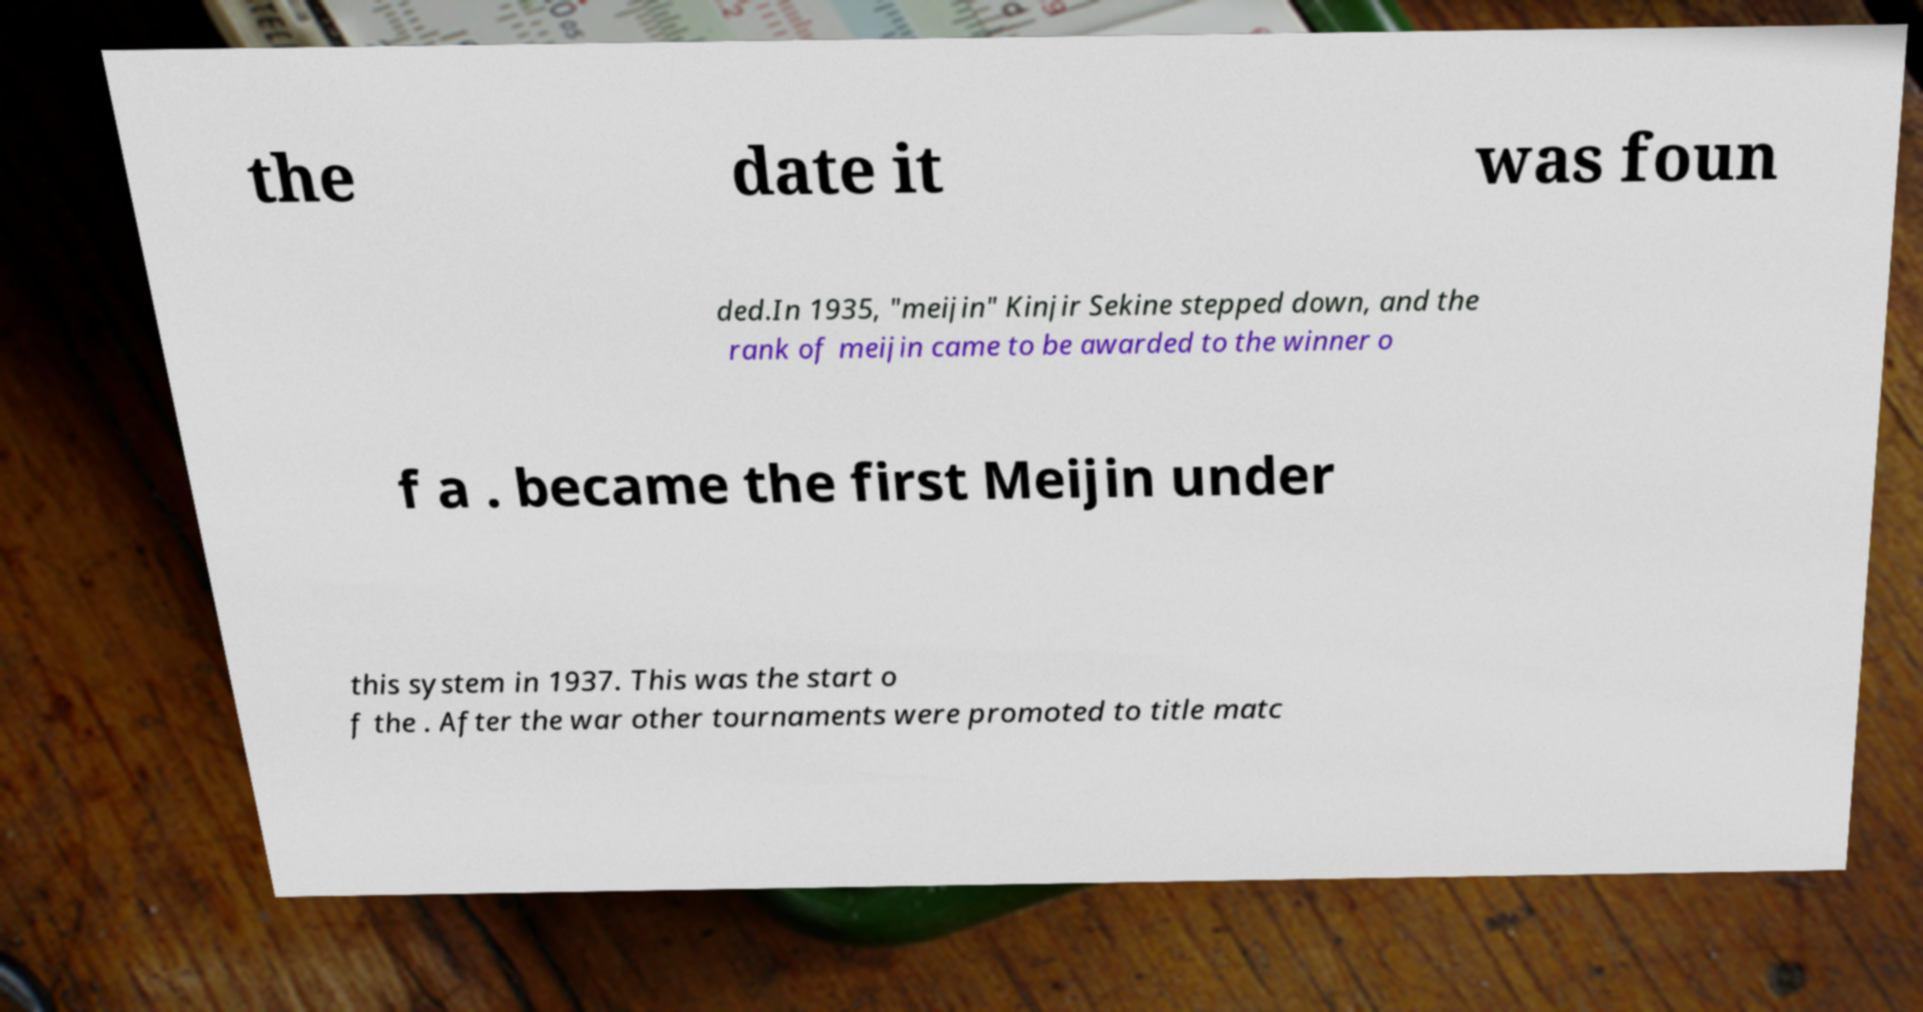Could you extract and type out the text from this image? the date it was foun ded.In 1935, "meijin" Kinjir Sekine stepped down, and the rank of meijin came to be awarded to the winner o f a . became the first Meijin under this system in 1937. This was the start o f the . After the war other tournaments were promoted to title matc 